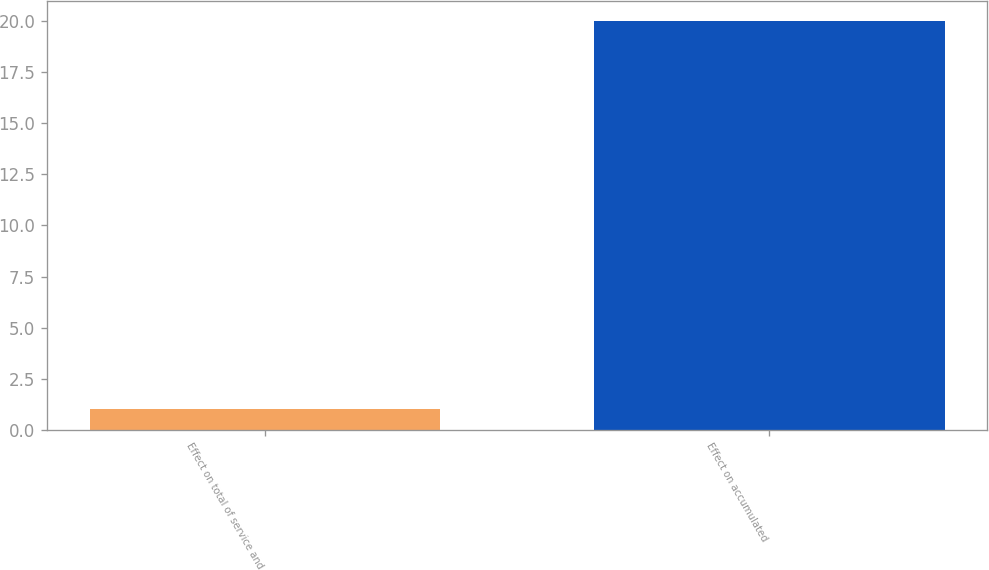Convert chart to OTSL. <chart><loc_0><loc_0><loc_500><loc_500><bar_chart><fcel>Effect on total of service and<fcel>Effect on accumulated<nl><fcel>1<fcel>20<nl></chart> 